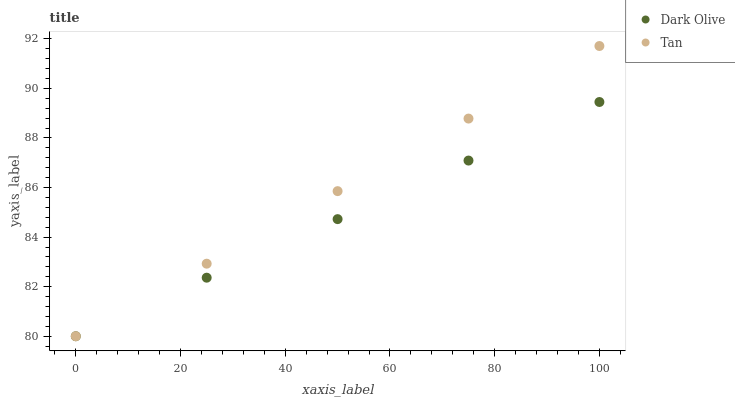Does Dark Olive have the minimum area under the curve?
Answer yes or no. Yes. Does Tan have the maximum area under the curve?
Answer yes or no. Yes. Does Dark Olive have the maximum area under the curve?
Answer yes or no. No. Is Tan the smoothest?
Answer yes or no. Yes. Is Dark Olive the roughest?
Answer yes or no. Yes. Is Dark Olive the smoothest?
Answer yes or no. No. Does Tan have the lowest value?
Answer yes or no. Yes. Does Tan have the highest value?
Answer yes or no. Yes. Does Dark Olive have the highest value?
Answer yes or no. No. Does Tan intersect Dark Olive?
Answer yes or no. Yes. Is Tan less than Dark Olive?
Answer yes or no. No. Is Tan greater than Dark Olive?
Answer yes or no. No. 